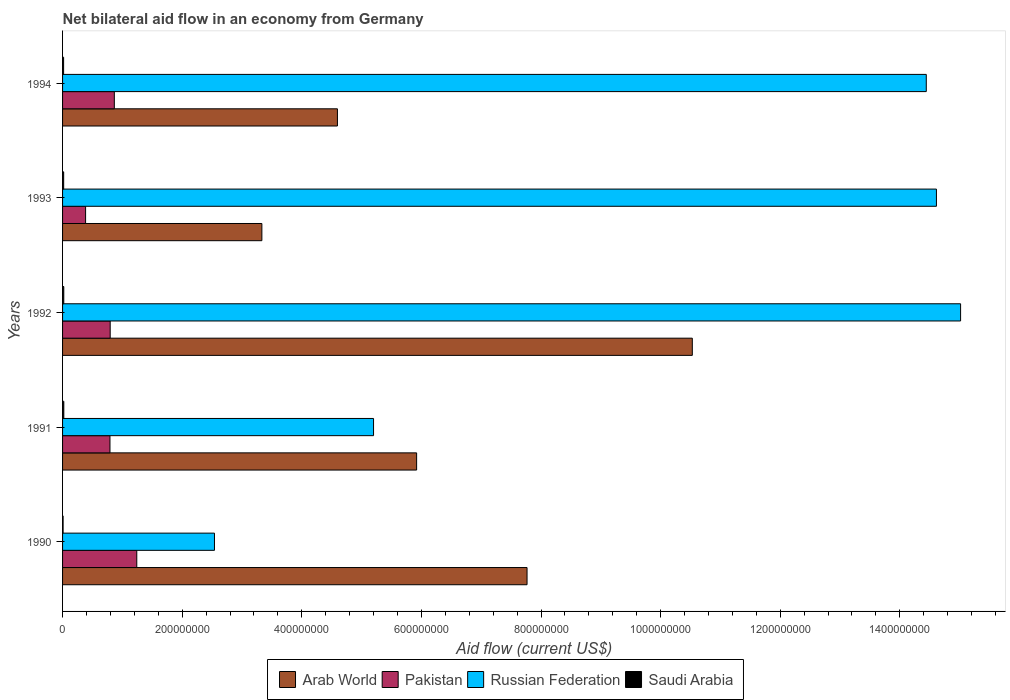How many different coloured bars are there?
Offer a very short reply. 4. Are the number of bars per tick equal to the number of legend labels?
Give a very brief answer. Yes. Are the number of bars on each tick of the Y-axis equal?
Provide a short and direct response. Yes. What is the net bilateral aid flow in Pakistan in 1990?
Your answer should be compact. 1.24e+08. Across all years, what is the maximum net bilateral aid flow in Arab World?
Offer a very short reply. 1.05e+09. Across all years, what is the minimum net bilateral aid flow in Russian Federation?
Make the answer very short. 2.54e+08. What is the total net bilateral aid flow in Arab World in the graph?
Provide a short and direct response. 3.21e+09. What is the difference between the net bilateral aid flow in Arab World in 1990 and the net bilateral aid flow in Russian Federation in 1993?
Offer a very short reply. -6.85e+08. What is the average net bilateral aid flow in Saudi Arabia per year?
Your response must be concise. 1.72e+06. In the year 1994, what is the difference between the net bilateral aid flow in Pakistan and net bilateral aid flow in Saudi Arabia?
Keep it short and to the point. 8.48e+07. In how many years, is the net bilateral aid flow in Saudi Arabia greater than 440000000 US$?
Your response must be concise. 0. What is the ratio of the net bilateral aid flow in Russian Federation in 1990 to that in 1994?
Make the answer very short. 0.18. Is the net bilateral aid flow in Russian Federation in 1991 less than that in 1992?
Make the answer very short. Yes. What is the difference between the highest and the second highest net bilateral aid flow in Arab World?
Ensure brevity in your answer.  2.76e+08. What is the difference between the highest and the lowest net bilateral aid flow in Saudi Arabia?
Your response must be concise. 1.20e+06. In how many years, is the net bilateral aid flow in Russian Federation greater than the average net bilateral aid flow in Russian Federation taken over all years?
Provide a short and direct response. 3. Is the sum of the net bilateral aid flow in Saudi Arabia in 1990 and 1992 greater than the maximum net bilateral aid flow in Pakistan across all years?
Your answer should be compact. No. Is it the case that in every year, the sum of the net bilateral aid flow in Pakistan and net bilateral aid flow in Saudi Arabia is greater than the sum of net bilateral aid flow in Russian Federation and net bilateral aid flow in Arab World?
Provide a succinct answer. Yes. What does the 4th bar from the top in 1990 represents?
Give a very brief answer. Arab World. Is it the case that in every year, the sum of the net bilateral aid flow in Saudi Arabia and net bilateral aid flow in Russian Federation is greater than the net bilateral aid flow in Pakistan?
Provide a short and direct response. Yes. How many bars are there?
Give a very brief answer. 20. Are the values on the major ticks of X-axis written in scientific E-notation?
Provide a short and direct response. No. Where does the legend appear in the graph?
Give a very brief answer. Bottom center. How many legend labels are there?
Your answer should be very brief. 4. How are the legend labels stacked?
Give a very brief answer. Horizontal. What is the title of the graph?
Make the answer very short. Net bilateral aid flow in an economy from Germany. What is the Aid flow (current US$) of Arab World in 1990?
Keep it short and to the point. 7.77e+08. What is the Aid flow (current US$) of Pakistan in 1990?
Provide a short and direct response. 1.24e+08. What is the Aid flow (current US$) in Russian Federation in 1990?
Make the answer very short. 2.54e+08. What is the Aid flow (current US$) in Saudi Arabia in 1990?
Offer a very short reply. 8.80e+05. What is the Aid flow (current US$) of Arab World in 1991?
Make the answer very short. 5.92e+08. What is the Aid flow (current US$) in Pakistan in 1991?
Make the answer very short. 7.93e+07. What is the Aid flow (current US$) of Russian Federation in 1991?
Offer a terse response. 5.20e+08. What is the Aid flow (current US$) in Saudi Arabia in 1991?
Provide a succinct answer. 2.08e+06. What is the Aid flow (current US$) in Arab World in 1992?
Provide a succinct answer. 1.05e+09. What is the Aid flow (current US$) of Pakistan in 1992?
Provide a short and direct response. 7.96e+07. What is the Aid flow (current US$) in Russian Federation in 1992?
Give a very brief answer. 1.50e+09. What is the Aid flow (current US$) of Saudi Arabia in 1992?
Make the answer very short. 2.03e+06. What is the Aid flow (current US$) in Arab World in 1993?
Your answer should be very brief. 3.33e+08. What is the Aid flow (current US$) in Pakistan in 1993?
Give a very brief answer. 3.85e+07. What is the Aid flow (current US$) in Russian Federation in 1993?
Give a very brief answer. 1.46e+09. What is the Aid flow (current US$) in Saudi Arabia in 1993?
Provide a succinct answer. 1.85e+06. What is the Aid flow (current US$) of Arab World in 1994?
Offer a terse response. 4.60e+08. What is the Aid flow (current US$) in Pakistan in 1994?
Give a very brief answer. 8.65e+07. What is the Aid flow (current US$) in Russian Federation in 1994?
Ensure brevity in your answer.  1.44e+09. What is the Aid flow (current US$) in Saudi Arabia in 1994?
Provide a short and direct response. 1.74e+06. Across all years, what is the maximum Aid flow (current US$) of Arab World?
Offer a very short reply. 1.05e+09. Across all years, what is the maximum Aid flow (current US$) in Pakistan?
Your answer should be compact. 1.24e+08. Across all years, what is the maximum Aid flow (current US$) in Russian Federation?
Provide a succinct answer. 1.50e+09. Across all years, what is the maximum Aid flow (current US$) of Saudi Arabia?
Offer a terse response. 2.08e+06. Across all years, what is the minimum Aid flow (current US$) of Arab World?
Provide a succinct answer. 3.33e+08. Across all years, what is the minimum Aid flow (current US$) of Pakistan?
Make the answer very short. 3.85e+07. Across all years, what is the minimum Aid flow (current US$) of Russian Federation?
Keep it short and to the point. 2.54e+08. Across all years, what is the minimum Aid flow (current US$) in Saudi Arabia?
Give a very brief answer. 8.80e+05. What is the total Aid flow (current US$) of Arab World in the graph?
Keep it short and to the point. 3.21e+09. What is the total Aid flow (current US$) of Pakistan in the graph?
Offer a very short reply. 4.08e+08. What is the total Aid flow (current US$) in Russian Federation in the graph?
Offer a terse response. 5.18e+09. What is the total Aid flow (current US$) in Saudi Arabia in the graph?
Provide a short and direct response. 8.58e+06. What is the difference between the Aid flow (current US$) of Arab World in 1990 and that in 1991?
Ensure brevity in your answer.  1.85e+08. What is the difference between the Aid flow (current US$) in Pakistan in 1990 and that in 1991?
Make the answer very short. 4.48e+07. What is the difference between the Aid flow (current US$) in Russian Federation in 1990 and that in 1991?
Your answer should be compact. -2.66e+08. What is the difference between the Aid flow (current US$) in Saudi Arabia in 1990 and that in 1991?
Make the answer very short. -1.20e+06. What is the difference between the Aid flow (current US$) of Arab World in 1990 and that in 1992?
Provide a short and direct response. -2.76e+08. What is the difference between the Aid flow (current US$) of Pakistan in 1990 and that in 1992?
Offer a terse response. 4.44e+07. What is the difference between the Aid flow (current US$) in Russian Federation in 1990 and that in 1992?
Give a very brief answer. -1.25e+09. What is the difference between the Aid flow (current US$) in Saudi Arabia in 1990 and that in 1992?
Your answer should be compact. -1.15e+06. What is the difference between the Aid flow (current US$) in Arab World in 1990 and that in 1993?
Provide a short and direct response. 4.43e+08. What is the difference between the Aid flow (current US$) in Pakistan in 1990 and that in 1993?
Provide a short and direct response. 8.56e+07. What is the difference between the Aid flow (current US$) of Russian Federation in 1990 and that in 1993?
Your answer should be compact. -1.21e+09. What is the difference between the Aid flow (current US$) in Saudi Arabia in 1990 and that in 1993?
Your answer should be very brief. -9.70e+05. What is the difference between the Aid flow (current US$) of Arab World in 1990 and that in 1994?
Provide a succinct answer. 3.17e+08. What is the difference between the Aid flow (current US$) of Pakistan in 1990 and that in 1994?
Provide a short and direct response. 3.76e+07. What is the difference between the Aid flow (current US$) in Russian Federation in 1990 and that in 1994?
Ensure brevity in your answer.  -1.19e+09. What is the difference between the Aid flow (current US$) of Saudi Arabia in 1990 and that in 1994?
Ensure brevity in your answer.  -8.60e+05. What is the difference between the Aid flow (current US$) in Arab World in 1991 and that in 1992?
Ensure brevity in your answer.  -4.61e+08. What is the difference between the Aid flow (current US$) of Pakistan in 1991 and that in 1992?
Offer a terse response. -3.80e+05. What is the difference between the Aid flow (current US$) in Russian Federation in 1991 and that in 1992?
Your response must be concise. -9.82e+08. What is the difference between the Aid flow (current US$) of Arab World in 1991 and that in 1993?
Ensure brevity in your answer.  2.59e+08. What is the difference between the Aid flow (current US$) in Pakistan in 1991 and that in 1993?
Offer a terse response. 4.08e+07. What is the difference between the Aid flow (current US$) of Russian Federation in 1991 and that in 1993?
Your answer should be very brief. -9.41e+08. What is the difference between the Aid flow (current US$) of Saudi Arabia in 1991 and that in 1993?
Your answer should be compact. 2.30e+05. What is the difference between the Aid flow (current US$) of Arab World in 1991 and that in 1994?
Make the answer very short. 1.32e+08. What is the difference between the Aid flow (current US$) in Pakistan in 1991 and that in 1994?
Offer a terse response. -7.28e+06. What is the difference between the Aid flow (current US$) in Russian Federation in 1991 and that in 1994?
Your answer should be very brief. -9.24e+08. What is the difference between the Aid flow (current US$) in Saudi Arabia in 1991 and that in 1994?
Make the answer very short. 3.40e+05. What is the difference between the Aid flow (current US$) of Arab World in 1992 and that in 1993?
Your answer should be compact. 7.20e+08. What is the difference between the Aid flow (current US$) in Pakistan in 1992 and that in 1993?
Your answer should be compact. 4.11e+07. What is the difference between the Aid flow (current US$) in Russian Federation in 1992 and that in 1993?
Ensure brevity in your answer.  4.04e+07. What is the difference between the Aid flow (current US$) in Saudi Arabia in 1992 and that in 1993?
Your answer should be very brief. 1.80e+05. What is the difference between the Aid flow (current US$) in Arab World in 1992 and that in 1994?
Your answer should be very brief. 5.93e+08. What is the difference between the Aid flow (current US$) of Pakistan in 1992 and that in 1994?
Ensure brevity in your answer.  -6.90e+06. What is the difference between the Aid flow (current US$) in Russian Federation in 1992 and that in 1994?
Offer a very short reply. 5.74e+07. What is the difference between the Aid flow (current US$) in Saudi Arabia in 1992 and that in 1994?
Your answer should be very brief. 2.90e+05. What is the difference between the Aid flow (current US$) of Arab World in 1993 and that in 1994?
Keep it short and to the point. -1.26e+08. What is the difference between the Aid flow (current US$) of Pakistan in 1993 and that in 1994?
Keep it short and to the point. -4.80e+07. What is the difference between the Aid flow (current US$) in Russian Federation in 1993 and that in 1994?
Make the answer very short. 1.70e+07. What is the difference between the Aid flow (current US$) in Saudi Arabia in 1993 and that in 1994?
Your response must be concise. 1.10e+05. What is the difference between the Aid flow (current US$) of Arab World in 1990 and the Aid flow (current US$) of Pakistan in 1991?
Offer a terse response. 6.97e+08. What is the difference between the Aid flow (current US$) of Arab World in 1990 and the Aid flow (current US$) of Russian Federation in 1991?
Offer a terse response. 2.57e+08. What is the difference between the Aid flow (current US$) of Arab World in 1990 and the Aid flow (current US$) of Saudi Arabia in 1991?
Your response must be concise. 7.75e+08. What is the difference between the Aid flow (current US$) in Pakistan in 1990 and the Aid flow (current US$) in Russian Federation in 1991?
Give a very brief answer. -3.96e+08. What is the difference between the Aid flow (current US$) in Pakistan in 1990 and the Aid flow (current US$) in Saudi Arabia in 1991?
Make the answer very short. 1.22e+08. What is the difference between the Aid flow (current US$) of Russian Federation in 1990 and the Aid flow (current US$) of Saudi Arabia in 1991?
Your answer should be very brief. 2.52e+08. What is the difference between the Aid flow (current US$) of Arab World in 1990 and the Aid flow (current US$) of Pakistan in 1992?
Your answer should be very brief. 6.97e+08. What is the difference between the Aid flow (current US$) in Arab World in 1990 and the Aid flow (current US$) in Russian Federation in 1992?
Ensure brevity in your answer.  -7.25e+08. What is the difference between the Aid flow (current US$) of Arab World in 1990 and the Aid flow (current US$) of Saudi Arabia in 1992?
Provide a succinct answer. 7.75e+08. What is the difference between the Aid flow (current US$) of Pakistan in 1990 and the Aid flow (current US$) of Russian Federation in 1992?
Make the answer very short. -1.38e+09. What is the difference between the Aid flow (current US$) in Pakistan in 1990 and the Aid flow (current US$) in Saudi Arabia in 1992?
Offer a terse response. 1.22e+08. What is the difference between the Aid flow (current US$) in Russian Federation in 1990 and the Aid flow (current US$) in Saudi Arabia in 1992?
Keep it short and to the point. 2.52e+08. What is the difference between the Aid flow (current US$) of Arab World in 1990 and the Aid flow (current US$) of Pakistan in 1993?
Keep it short and to the point. 7.38e+08. What is the difference between the Aid flow (current US$) in Arab World in 1990 and the Aid flow (current US$) in Russian Federation in 1993?
Offer a terse response. -6.85e+08. What is the difference between the Aid flow (current US$) of Arab World in 1990 and the Aid flow (current US$) of Saudi Arabia in 1993?
Offer a very short reply. 7.75e+08. What is the difference between the Aid flow (current US$) of Pakistan in 1990 and the Aid flow (current US$) of Russian Federation in 1993?
Your answer should be compact. -1.34e+09. What is the difference between the Aid flow (current US$) of Pakistan in 1990 and the Aid flow (current US$) of Saudi Arabia in 1993?
Provide a succinct answer. 1.22e+08. What is the difference between the Aid flow (current US$) in Russian Federation in 1990 and the Aid flow (current US$) in Saudi Arabia in 1993?
Keep it short and to the point. 2.52e+08. What is the difference between the Aid flow (current US$) in Arab World in 1990 and the Aid flow (current US$) in Pakistan in 1994?
Your response must be concise. 6.90e+08. What is the difference between the Aid flow (current US$) of Arab World in 1990 and the Aid flow (current US$) of Russian Federation in 1994?
Make the answer very short. -6.68e+08. What is the difference between the Aid flow (current US$) of Arab World in 1990 and the Aid flow (current US$) of Saudi Arabia in 1994?
Your answer should be very brief. 7.75e+08. What is the difference between the Aid flow (current US$) in Pakistan in 1990 and the Aid flow (current US$) in Russian Federation in 1994?
Provide a short and direct response. -1.32e+09. What is the difference between the Aid flow (current US$) of Pakistan in 1990 and the Aid flow (current US$) of Saudi Arabia in 1994?
Give a very brief answer. 1.22e+08. What is the difference between the Aid flow (current US$) in Russian Federation in 1990 and the Aid flow (current US$) in Saudi Arabia in 1994?
Give a very brief answer. 2.52e+08. What is the difference between the Aid flow (current US$) of Arab World in 1991 and the Aid flow (current US$) of Pakistan in 1992?
Give a very brief answer. 5.12e+08. What is the difference between the Aid flow (current US$) of Arab World in 1991 and the Aid flow (current US$) of Russian Federation in 1992?
Give a very brief answer. -9.10e+08. What is the difference between the Aid flow (current US$) of Arab World in 1991 and the Aid flow (current US$) of Saudi Arabia in 1992?
Offer a very short reply. 5.90e+08. What is the difference between the Aid flow (current US$) of Pakistan in 1991 and the Aid flow (current US$) of Russian Federation in 1992?
Your answer should be compact. -1.42e+09. What is the difference between the Aid flow (current US$) of Pakistan in 1991 and the Aid flow (current US$) of Saudi Arabia in 1992?
Offer a terse response. 7.72e+07. What is the difference between the Aid flow (current US$) of Russian Federation in 1991 and the Aid flow (current US$) of Saudi Arabia in 1992?
Provide a succinct answer. 5.18e+08. What is the difference between the Aid flow (current US$) of Arab World in 1991 and the Aid flow (current US$) of Pakistan in 1993?
Provide a succinct answer. 5.54e+08. What is the difference between the Aid flow (current US$) of Arab World in 1991 and the Aid flow (current US$) of Russian Federation in 1993?
Your answer should be compact. -8.69e+08. What is the difference between the Aid flow (current US$) in Arab World in 1991 and the Aid flow (current US$) in Saudi Arabia in 1993?
Offer a very short reply. 5.90e+08. What is the difference between the Aid flow (current US$) of Pakistan in 1991 and the Aid flow (current US$) of Russian Federation in 1993?
Offer a terse response. -1.38e+09. What is the difference between the Aid flow (current US$) in Pakistan in 1991 and the Aid flow (current US$) in Saudi Arabia in 1993?
Provide a succinct answer. 7.74e+07. What is the difference between the Aid flow (current US$) of Russian Federation in 1991 and the Aid flow (current US$) of Saudi Arabia in 1993?
Provide a short and direct response. 5.18e+08. What is the difference between the Aid flow (current US$) in Arab World in 1991 and the Aid flow (current US$) in Pakistan in 1994?
Provide a short and direct response. 5.06e+08. What is the difference between the Aid flow (current US$) of Arab World in 1991 and the Aid flow (current US$) of Russian Federation in 1994?
Offer a very short reply. -8.52e+08. What is the difference between the Aid flow (current US$) in Arab World in 1991 and the Aid flow (current US$) in Saudi Arabia in 1994?
Offer a terse response. 5.90e+08. What is the difference between the Aid flow (current US$) in Pakistan in 1991 and the Aid flow (current US$) in Russian Federation in 1994?
Your answer should be compact. -1.36e+09. What is the difference between the Aid flow (current US$) in Pakistan in 1991 and the Aid flow (current US$) in Saudi Arabia in 1994?
Offer a very short reply. 7.75e+07. What is the difference between the Aid flow (current US$) of Russian Federation in 1991 and the Aid flow (current US$) of Saudi Arabia in 1994?
Provide a short and direct response. 5.18e+08. What is the difference between the Aid flow (current US$) of Arab World in 1992 and the Aid flow (current US$) of Pakistan in 1993?
Keep it short and to the point. 1.01e+09. What is the difference between the Aid flow (current US$) in Arab World in 1992 and the Aid flow (current US$) in Russian Federation in 1993?
Ensure brevity in your answer.  -4.08e+08. What is the difference between the Aid flow (current US$) of Arab World in 1992 and the Aid flow (current US$) of Saudi Arabia in 1993?
Your answer should be compact. 1.05e+09. What is the difference between the Aid flow (current US$) in Pakistan in 1992 and the Aid flow (current US$) in Russian Federation in 1993?
Your answer should be compact. -1.38e+09. What is the difference between the Aid flow (current US$) of Pakistan in 1992 and the Aid flow (current US$) of Saudi Arabia in 1993?
Your answer should be compact. 7.78e+07. What is the difference between the Aid flow (current US$) of Russian Federation in 1992 and the Aid flow (current US$) of Saudi Arabia in 1993?
Offer a terse response. 1.50e+09. What is the difference between the Aid flow (current US$) in Arab World in 1992 and the Aid flow (current US$) in Pakistan in 1994?
Offer a terse response. 9.66e+08. What is the difference between the Aid flow (current US$) of Arab World in 1992 and the Aid flow (current US$) of Russian Federation in 1994?
Ensure brevity in your answer.  -3.91e+08. What is the difference between the Aid flow (current US$) in Arab World in 1992 and the Aid flow (current US$) in Saudi Arabia in 1994?
Keep it short and to the point. 1.05e+09. What is the difference between the Aid flow (current US$) in Pakistan in 1992 and the Aid flow (current US$) in Russian Federation in 1994?
Provide a succinct answer. -1.36e+09. What is the difference between the Aid flow (current US$) in Pakistan in 1992 and the Aid flow (current US$) in Saudi Arabia in 1994?
Provide a short and direct response. 7.79e+07. What is the difference between the Aid flow (current US$) in Russian Federation in 1992 and the Aid flow (current US$) in Saudi Arabia in 1994?
Provide a succinct answer. 1.50e+09. What is the difference between the Aid flow (current US$) of Arab World in 1993 and the Aid flow (current US$) of Pakistan in 1994?
Your answer should be compact. 2.47e+08. What is the difference between the Aid flow (current US$) in Arab World in 1993 and the Aid flow (current US$) in Russian Federation in 1994?
Provide a short and direct response. -1.11e+09. What is the difference between the Aid flow (current US$) of Arab World in 1993 and the Aid flow (current US$) of Saudi Arabia in 1994?
Provide a short and direct response. 3.32e+08. What is the difference between the Aid flow (current US$) in Pakistan in 1993 and the Aid flow (current US$) in Russian Federation in 1994?
Your answer should be very brief. -1.41e+09. What is the difference between the Aid flow (current US$) in Pakistan in 1993 and the Aid flow (current US$) in Saudi Arabia in 1994?
Your answer should be compact. 3.68e+07. What is the difference between the Aid flow (current US$) of Russian Federation in 1993 and the Aid flow (current US$) of Saudi Arabia in 1994?
Give a very brief answer. 1.46e+09. What is the average Aid flow (current US$) of Arab World per year?
Your answer should be compact. 6.43e+08. What is the average Aid flow (current US$) in Pakistan per year?
Keep it short and to the point. 8.16e+07. What is the average Aid flow (current US$) in Russian Federation per year?
Provide a short and direct response. 1.04e+09. What is the average Aid flow (current US$) of Saudi Arabia per year?
Your answer should be compact. 1.72e+06. In the year 1990, what is the difference between the Aid flow (current US$) in Arab World and Aid flow (current US$) in Pakistan?
Your answer should be very brief. 6.53e+08. In the year 1990, what is the difference between the Aid flow (current US$) in Arab World and Aid flow (current US$) in Russian Federation?
Offer a terse response. 5.23e+08. In the year 1990, what is the difference between the Aid flow (current US$) in Arab World and Aid flow (current US$) in Saudi Arabia?
Make the answer very short. 7.76e+08. In the year 1990, what is the difference between the Aid flow (current US$) in Pakistan and Aid flow (current US$) in Russian Federation?
Offer a very short reply. -1.30e+08. In the year 1990, what is the difference between the Aid flow (current US$) of Pakistan and Aid flow (current US$) of Saudi Arabia?
Your answer should be very brief. 1.23e+08. In the year 1990, what is the difference between the Aid flow (current US$) in Russian Federation and Aid flow (current US$) in Saudi Arabia?
Your answer should be very brief. 2.53e+08. In the year 1991, what is the difference between the Aid flow (current US$) of Arab World and Aid flow (current US$) of Pakistan?
Provide a succinct answer. 5.13e+08. In the year 1991, what is the difference between the Aid flow (current US$) in Arab World and Aid flow (current US$) in Russian Federation?
Provide a short and direct response. 7.20e+07. In the year 1991, what is the difference between the Aid flow (current US$) of Arab World and Aid flow (current US$) of Saudi Arabia?
Your answer should be compact. 5.90e+08. In the year 1991, what is the difference between the Aid flow (current US$) of Pakistan and Aid flow (current US$) of Russian Federation?
Your answer should be very brief. -4.41e+08. In the year 1991, what is the difference between the Aid flow (current US$) in Pakistan and Aid flow (current US$) in Saudi Arabia?
Offer a very short reply. 7.72e+07. In the year 1991, what is the difference between the Aid flow (current US$) in Russian Federation and Aid flow (current US$) in Saudi Arabia?
Offer a terse response. 5.18e+08. In the year 1992, what is the difference between the Aid flow (current US$) in Arab World and Aid flow (current US$) in Pakistan?
Keep it short and to the point. 9.73e+08. In the year 1992, what is the difference between the Aid flow (current US$) of Arab World and Aid flow (current US$) of Russian Federation?
Give a very brief answer. -4.49e+08. In the year 1992, what is the difference between the Aid flow (current US$) in Arab World and Aid flow (current US$) in Saudi Arabia?
Provide a short and direct response. 1.05e+09. In the year 1992, what is the difference between the Aid flow (current US$) in Pakistan and Aid flow (current US$) in Russian Federation?
Your response must be concise. -1.42e+09. In the year 1992, what is the difference between the Aid flow (current US$) of Pakistan and Aid flow (current US$) of Saudi Arabia?
Provide a succinct answer. 7.76e+07. In the year 1992, what is the difference between the Aid flow (current US$) of Russian Federation and Aid flow (current US$) of Saudi Arabia?
Make the answer very short. 1.50e+09. In the year 1993, what is the difference between the Aid flow (current US$) in Arab World and Aid flow (current US$) in Pakistan?
Offer a very short reply. 2.95e+08. In the year 1993, what is the difference between the Aid flow (current US$) of Arab World and Aid flow (current US$) of Russian Federation?
Make the answer very short. -1.13e+09. In the year 1993, what is the difference between the Aid flow (current US$) of Arab World and Aid flow (current US$) of Saudi Arabia?
Your answer should be compact. 3.31e+08. In the year 1993, what is the difference between the Aid flow (current US$) in Pakistan and Aid flow (current US$) in Russian Federation?
Provide a short and direct response. -1.42e+09. In the year 1993, what is the difference between the Aid flow (current US$) of Pakistan and Aid flow (current US$) of Saudi Arabia?
Your answer should be very brief. 3.67e+07. In the year 1993, what is the difference between the Aid flow (current US$) in Russian Federation and Aid flow (current US$) in Saudi Arabia?
Offer a very short reply. 1.46e+09. In the year 1994, what is the difference between the Aid flow (current US$) in Arab World and Aid flow (current US$) in Pakistan?
Your answer should be very brief. 3.73e+08. In the year 1994, what is the difference between the Aid flow (current US$) in Arab World and Aid flow (current US$) in Russian Federation?
Provide a short and direct response. -9.85e+08. In the year 1994, what is the difference between the Aid flow (current US$) of Arab World and Aid flow (current US$) of Saudi Arabia?
Keep it short and to the point. 4.58e+08. In the year 1994, what is the difference between the Aid flow (current US$) of Pakistan and Aid flow (current US$) of Russian Federation?
Give a very brief answer. -1.36e+09. In the year 1994, what is the difference between the Aid flow (current US$) of Pakistan and Aid flow (current US$) of Saudi Arabia?
Offer a terse response. 8.48e+07. In the year 1994, what is the difference between the Aid flow (current US$) in Russian Federation and Aid flow (current US$) in Saudi Arabia?
Ensure brevity in your answer.  1.44e+09. What is the ratio of the Aid flow (current US$) in Arab World in 1990 to that in 1991?
Your answer should be very brief. 1.31. What is the ratio of the Aid flow (current US$) of Pakistan in 1990 to that in 1991?
Offer a terse response. 1.57. What is the ratio of the Aid flow (current US$) in Russian Federation in 1990 to that in 1991?
Your response must be concise. 0.49. What is the ratio of the Aid flow (current US$) of Saudi Arabia in 1990 to that in 1991?
Your response must be concise. 0.42. What is the ratio of the Aid flow (current US$) in Arab World in 1990 to that in 1992?
Make the answer very short. 0.74. What is the ratio of the Aid flow (current US$) of Pakistan in 1990 to that in 1992?
Your answer should be very brief. 1.56. What is the ratio of the Aid flow (current US$) in Russian Federation in 1990 to that in 1992?
Provide a short and direct response. 0.17. What is the ratio of the Aid flow (current US$) of Saudi Arabia in 1990 to that in 1992?
Your answer should be very brief. 0.43. What is the ratio of the Aid flow (current US$) in Arab World in 1990 to that in 1993?
Ensure brevity in your answer.  2.33. What is the ratio of the Aid flow (current US$) in Pakistan in 1990 to that in 1993?
Provide a succinct answer. 3.22. What is the ratio of the Aid flow (current US$) in Russian Federation in 1990 to that in 1993?
Your response must be concise. 0.17. What is the ratio of the Aid flow (current US$) of Saudi Arabia in 1990 to that in 1993?
Provide a short and direct response. 0.48. What is the ratio of the Aid flow (current US$) in Arab World in 1990 to that in 1994?
Your answer should be compact. 1.69. What is the ratio of the Aid flow (current US$) in Pakistan in 1990 to that in 1994?
Make the answer very short. 1.43. What is the ratio of the Aid flow (current US$) in Russian Federation in 1990 to that in 1994?
Ensure brevity in your answer.  0.18. What is the ratio of the Aid flow (current US$) of Saudi Arabia in 1990 to that in 1994?
Your answer should be compact. 0.51. What is the ratio of the Aid flow (current US$) in Arab World in 1991 to that in 1992?
Offer a very short reply. 0.56. What is the ratio of the Aid flow (current US$) of Pakistan in 1991 to that in 1992?
Make the answer very short. 1. What is the ratio of the Aid flow (current US$) in Russian Federation in 1991 to that in 1992?
Your response must be concise. 0.35. What is the ratio of the Aid flow (current US$) in Saudi Arabia in 1991 to that in 1992?
Provide a succinct answer. 1.02. What is the ratio of the Aid flow (current US$) in Arab World in 1991 to that in 1993?
Offer a very short reply. 1.78. What is the ratio of the Aid flow (current US$) of Pakistan in 1991 to that in 1993?
Provide a short and direct response. 2.06. What is the ratio of the Aid flow (current US$) in Russian Federation in 1991 to that in 1993?
Provide a succinct answer. 0.36. What is the ratio of the Aid flow (current US$) of Saudi Arabia in 1991 to that in 1993?
Your answer should be very brief. 1.12. What is the ratio of the Aid flow (current US$) in Arab World in 1991 to that in 1994?
Provide a short and direct response. 1.29. What is the ratio of the Aid flow (current US$) of Pakistan in 1991 to that in 1994?
Your answer should be compact. 0.92. What is the ratio of the Aid flow (current US$) in Russian Federation in 1991 to that in 1994?
Your answer should be compact. 0.36. What is the ratio of the Aid flow (current US$) of Saudi Arabia in 1991 to that in 1994?
Your response must be concise. 1.2. What is the ratio of the Aid flow (current US$) in Arab World in 1992 to that in 1993?
Ensure brevity in your answer.  3.16. What is the ratio of the Aid flow (current US$) in Pakistan in 1992 to that in 1993?
Give a very brief answer. 2.07. What is the ratio of the Aid flow (current US$) of Russian Federation in 1992 to that in 1993?
Your response must be concise. 1.03. What is the ratio of the Aid flow (current US$) in Saudi Arabia in 1992 to that in 1993?
Give a very brief answer. 1.1. What is the ratio of the Aid flow (current US$) in Arab World in 1992 to that in 1994?
Ensure brevity in your answer.  2.29. What is the ratio of the Aid flow (current US$) in Pakistan in 1992 to that in 1994?
Give a very brief answer. 0.92. What is the ratio of the Aid flow (current US$) in Russian Federation in 1992 to that in 1994?
Offer a terse response. 1.04. What is the ratio of the Aid flow (current US$) of Saudi Arabia in 1992 to that in 1994?
Make the answer very short. 1.17. What is the ratio of the Aid flow (current US$) of Arab World in 1993 to that in 1994?
Your answer should be very brief. 0.73. What is the ratio of the Aid flow (current US$) in Pakistan in 1993 to that in 1994?
Give a very brief answer. 0.45. What is the ratio of the Aid flow (current US$) of Russian Federation in 1993 to that in 1994?
Provide a succinct answer. 1.01. What is the ratio of the Aid flow (current US$) of Saudi Arabia in 1993 to that in 1994?
Offer a very short reply. 1.06. What is the difference between the highest and the second highest Aid flow (current US$) in Arab World?
Give a very brief answer. 2.76e+08. What is the difference between the highest and the second highest Aid flow (current US$) of Pakistan?
Offer a terse response. 3.76e+07. What is the difference between the highest and the second highest Aid flow (current US$) of Russian Federation?
Give a very brief answer. 4.04e+07. What is the difference between the highest and the second highest Aid flow (current US$) of Saudi Arabia?
Provide a succinct answer. 5.00e+04. What is the difference between the highest and the lowest Aid flow (current US$) of Arab World?
Your response must be concise. 7.20e+08. What is the difference between the highest and the lowest Aid flow (current US$) of Pakistan?
Your answer should be compact. 8.56e+07. What is the difference between the highest and the lowest Aid flow (current US$) of Russian Federation?
Your response must be concise. 1.25e+09. What is the difference between the highest and the lowest Aid flow (current US$) in Saudi Arabia?
Provide a short and direct response. 1.20e+06. 